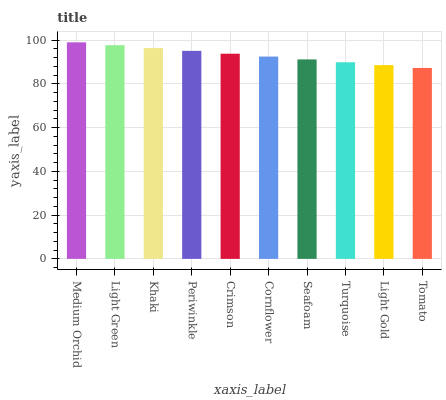Is Tomato the minimum?
Answer yes or no. Yes. Is Medium Orchid the maximum?
Answer yes or no. Yes. Is Light Green the minimum?
Answer yes or no. No. Is Light Green the maximum?
Answer yes or no. No. Is Medium Orchid greater than Light Green?
Answer yes or no. Yes. Is Light Green less than Medium Orchid?
Answer yes or no. Yes. Is Light Green greater than Medium Orchid?
Answer yes or no. No. Is Medium Orchid less than Light Green?
Answer yes or no. No. Is Crimson the high median?
Answer yes or no. Yes. Is Cornflower the low median?
Answer yes or no. Yes. Is Light Gold the high median?
Answer yes or no. No. Is Turquoise the low median?
Answer yes or no. No. 